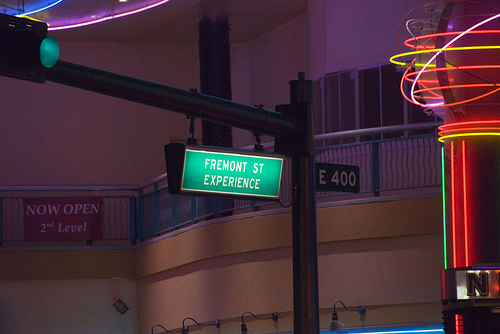Identify the text contained in this image. NOW OPEN FREMONT 400 EXPERIENCE N E Level 2nd ST 